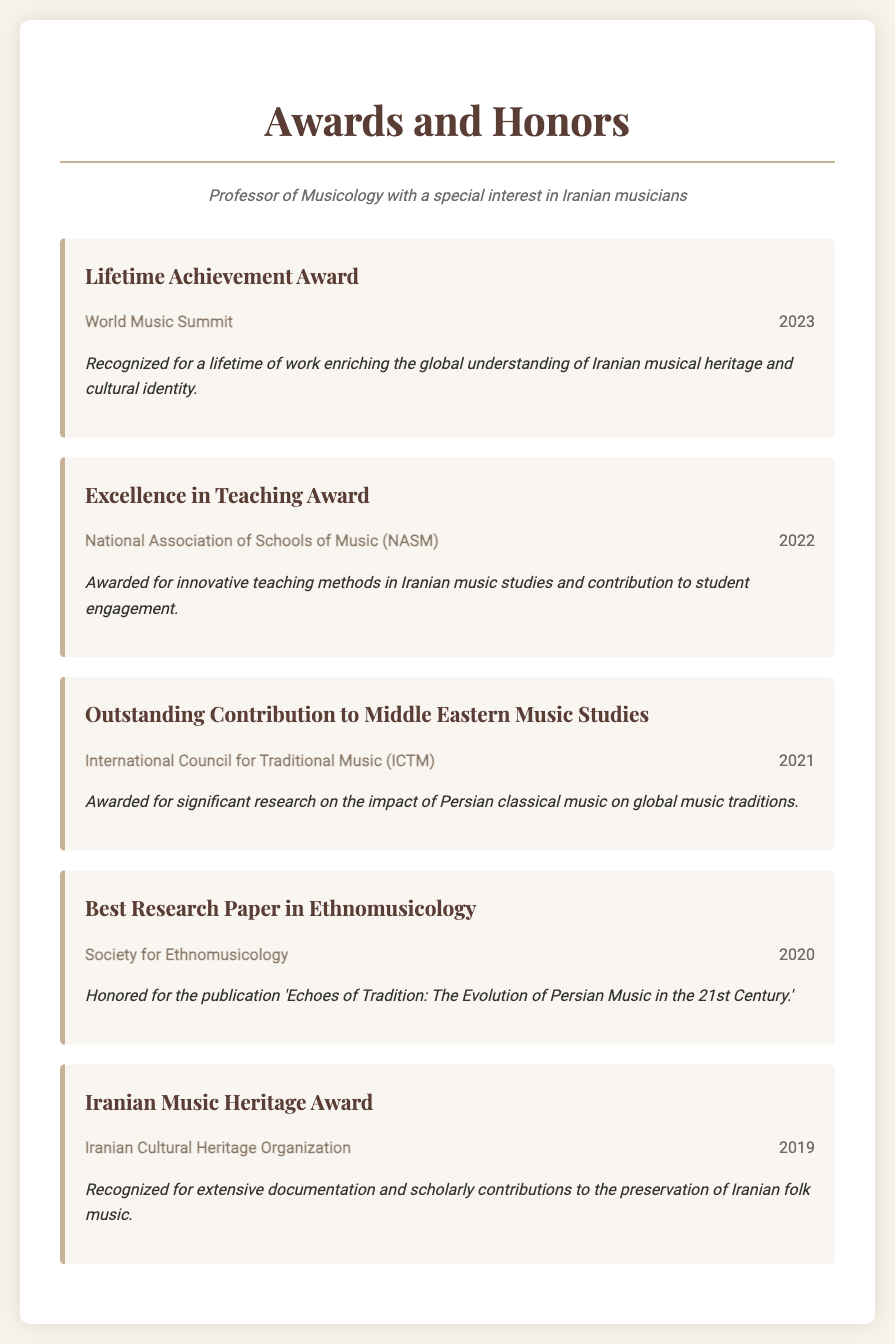What award did the professor receive in 2023? The award received in 2023 is the Lifetime Achievement Award, which acknowledges a lifetime of contributions to Iranian music.
Answer: Lifetime Achievement Award Which organization awarded the Excellence in Teaching Award? The Excellence in Teaching Award was awarded by the National Association of Schools of Music (NASM).
Answer: National Association of Schools of Music (NASM) In what year did the professor receive the Outstanding Contribution to Middle Eastern Music Studies? The award for Outstanding Contribution to Middle Eastern Music Studies was received in 2021.
Answer: 2021 What is the title of the best research paper recognized in 2020? The best research paper recognized in 2020 is titled 'Echoes of Tradition: The Evolution of Persian Music in the 21st Century.'
Answer: Echoes of Tradition: The Evolution of Persian Music in the 21st Century What is the primary focus of the Iranian Music Heritage Award? The Iranian Music Heritage Award focuses on the preservation of Iranian folk music.
Answer: Preservation of Iranian folk music How many awards are listed in the document? The document lists a total of five awards received by the professor.
Answer: Five Which year saw the award for Best Research Paper in Ethnomusicology? The Best Research Paper in Ethnomusicology was awarded in the year 2020.
Answer: 2020 Who awarded the Iranian Music Heritage Award? The Iranian Music Heritage Award was awarded by the Iranian Cultural Heritage Organization.
Answer: Iranian Cultural Heritage Organization 